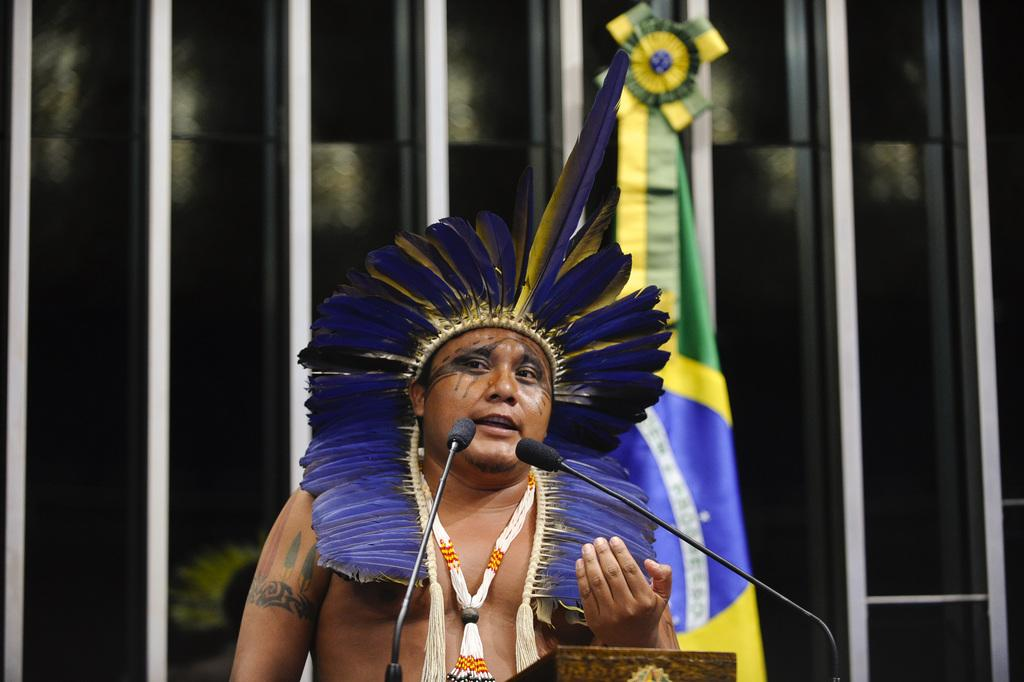What group of people is depicted in the image? There is a tribe in the image. What are the tribe members doing in the image? The tribe members are standing in front of two microphones. Is there any symbol or emblem visible in the image? Yes, there is a flag visible in the image. How many maids are present in the image? There are no maids present in the image; it features a tribe standing in front of two microphones. What type of bears can be seen interacting with the tribe members in the image? There are no bears present in the image; it features a tribe standing in front of two microphones. 